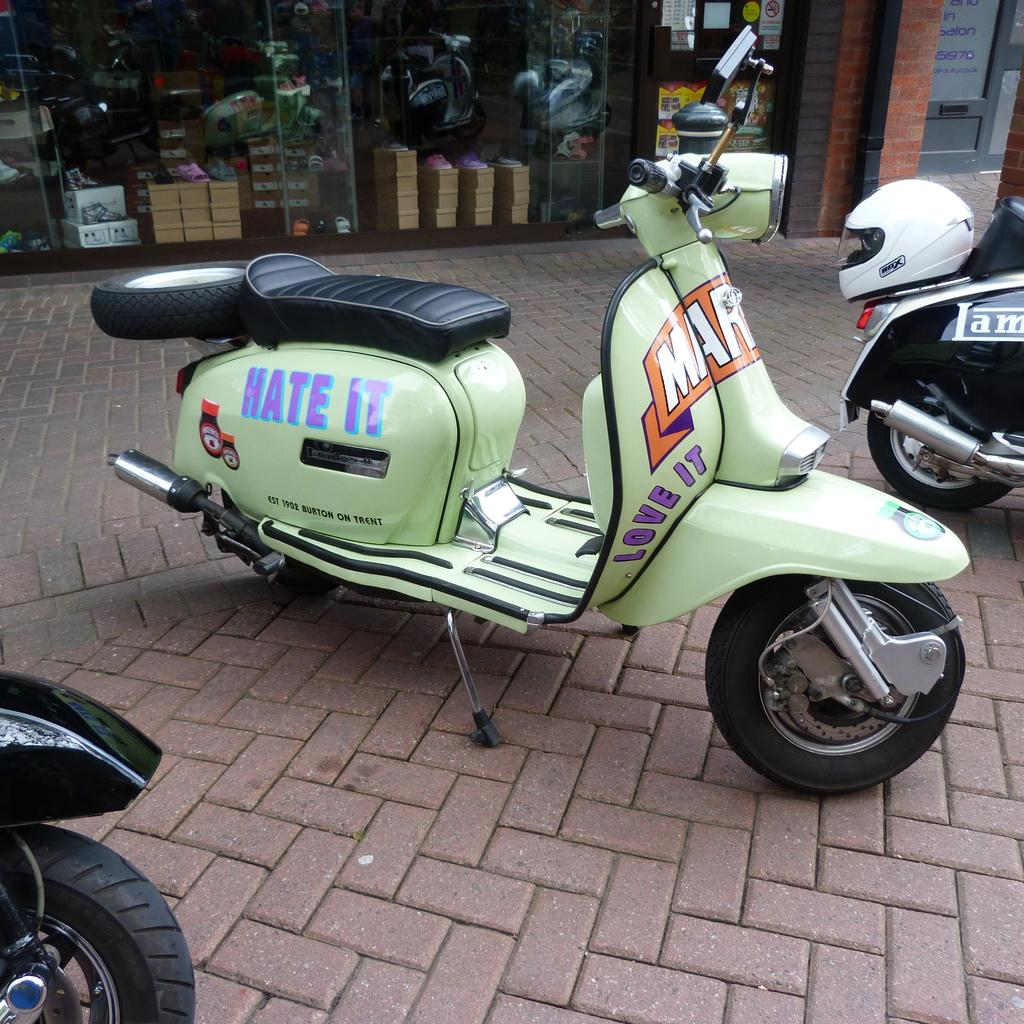What can be seen on the floor in the image? There are motorbikes on the floor in the image. What type of location is suggested by the background of the image? The background of the image appears to be a store. What else can be seen in the store besides the motorbikes? There are objects visible in the store. Can you describe the reaction of the river to the drain in the image? There is no river or drain present in the image, so it is not possible to describe any reaction between them. 